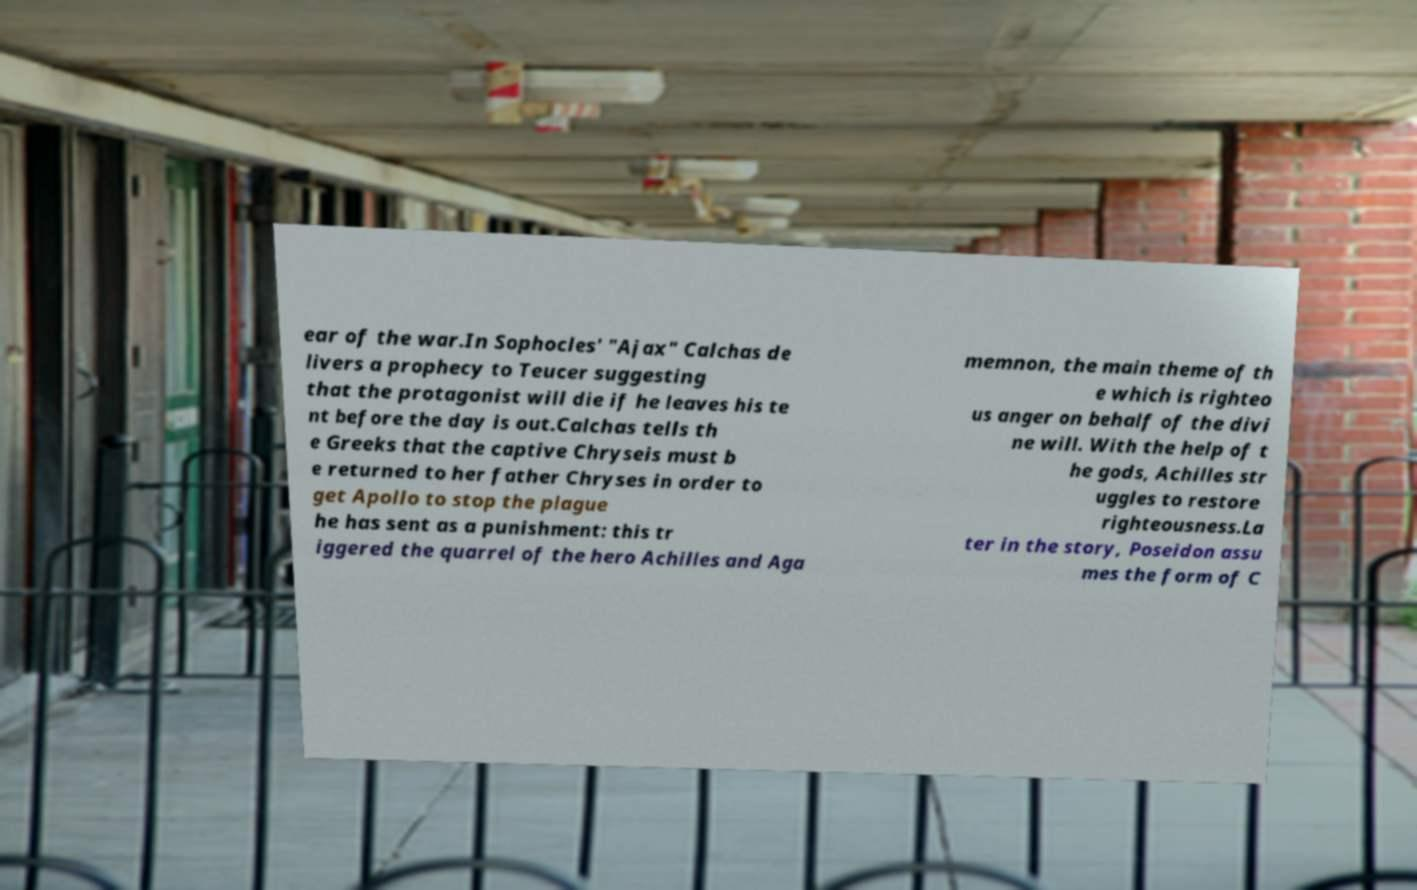Please read and relay the text visible in this image. What does it say? ear of the war.In Sophocles' "Ajax" Calchas de livers a prophecy to Teucer suggesting that the protagonist will die if he leaves his te nt before the day is out.Calchas tells th e Greeks that the captive Chryseis must b e returned to her father Chryses in order to get Apollo to stop the plague he has sent as a punishment: this tr iggered the quarrel of the hero Achilles and Aga memnon, the main theme of th e which is righteo us anger on behalf of the divi ne will. With the help of t he gods, Achilles str uggles to restore righteousness.La ter in the story, Poseidon assu mes the form of C 